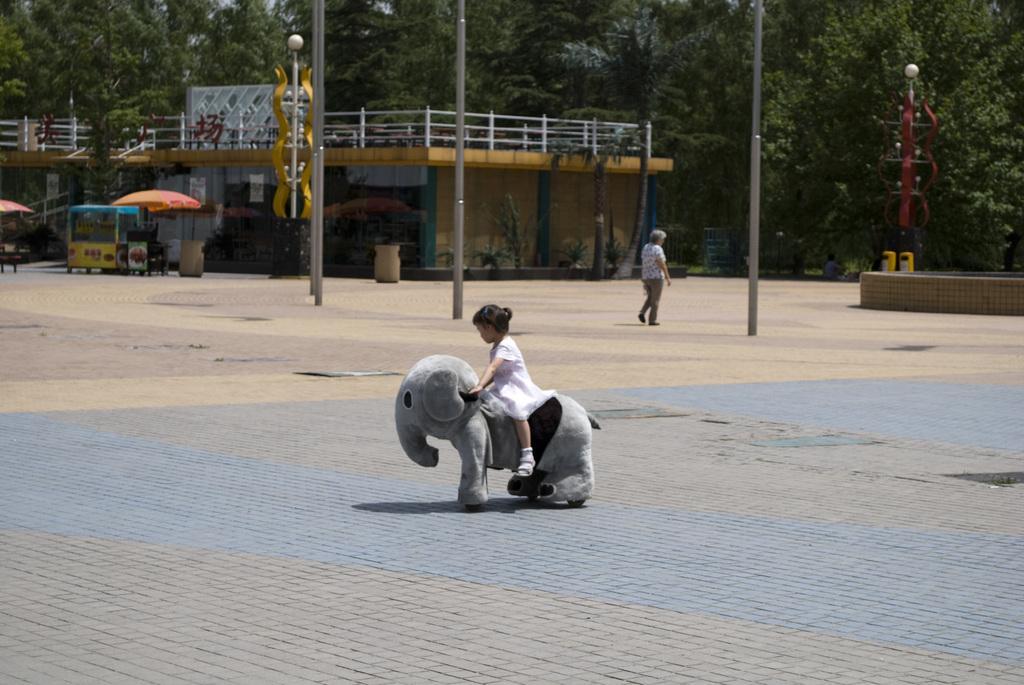In one or two sentences, can you explain what this image depicts? In this image we can see a child is sitting on the elephant which is on the ground. Here we can see a person is walking on the road, we can see poles, light poles, trash bin, stall, umbrellas, house and the trees in the background. 